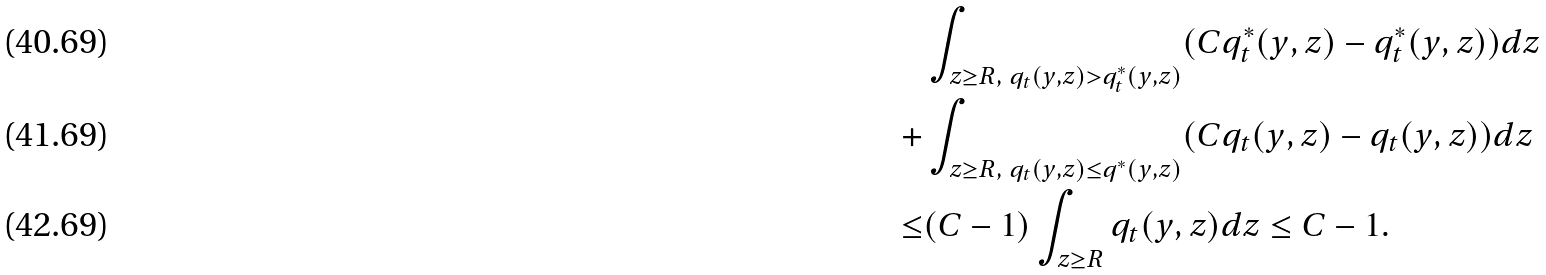<formula> <loc_0><loc_0><loc_500><loc_500>& \int _ { z \geq R , \ q _ { t } ( y , z ) > q ^ { * } _ { t } ( y , z ) } ( C q ^ { * } _ { t } ( y , z ) - q ^ { * } _ { t } ( y , z ) ) d z \\ + & \int _ { z \geq R , \ q _ { t } ( y , z ) \leq q ^ { * } ( y , z ) } ( C q _ { t } ( y , z ) - q _ { t } ( y , z ) ) d z \\ \leq & ( C - 1 ) \int _ { z \geq R } q _ { t } ( y , z ) d z \leq C - 1 .</formula> 